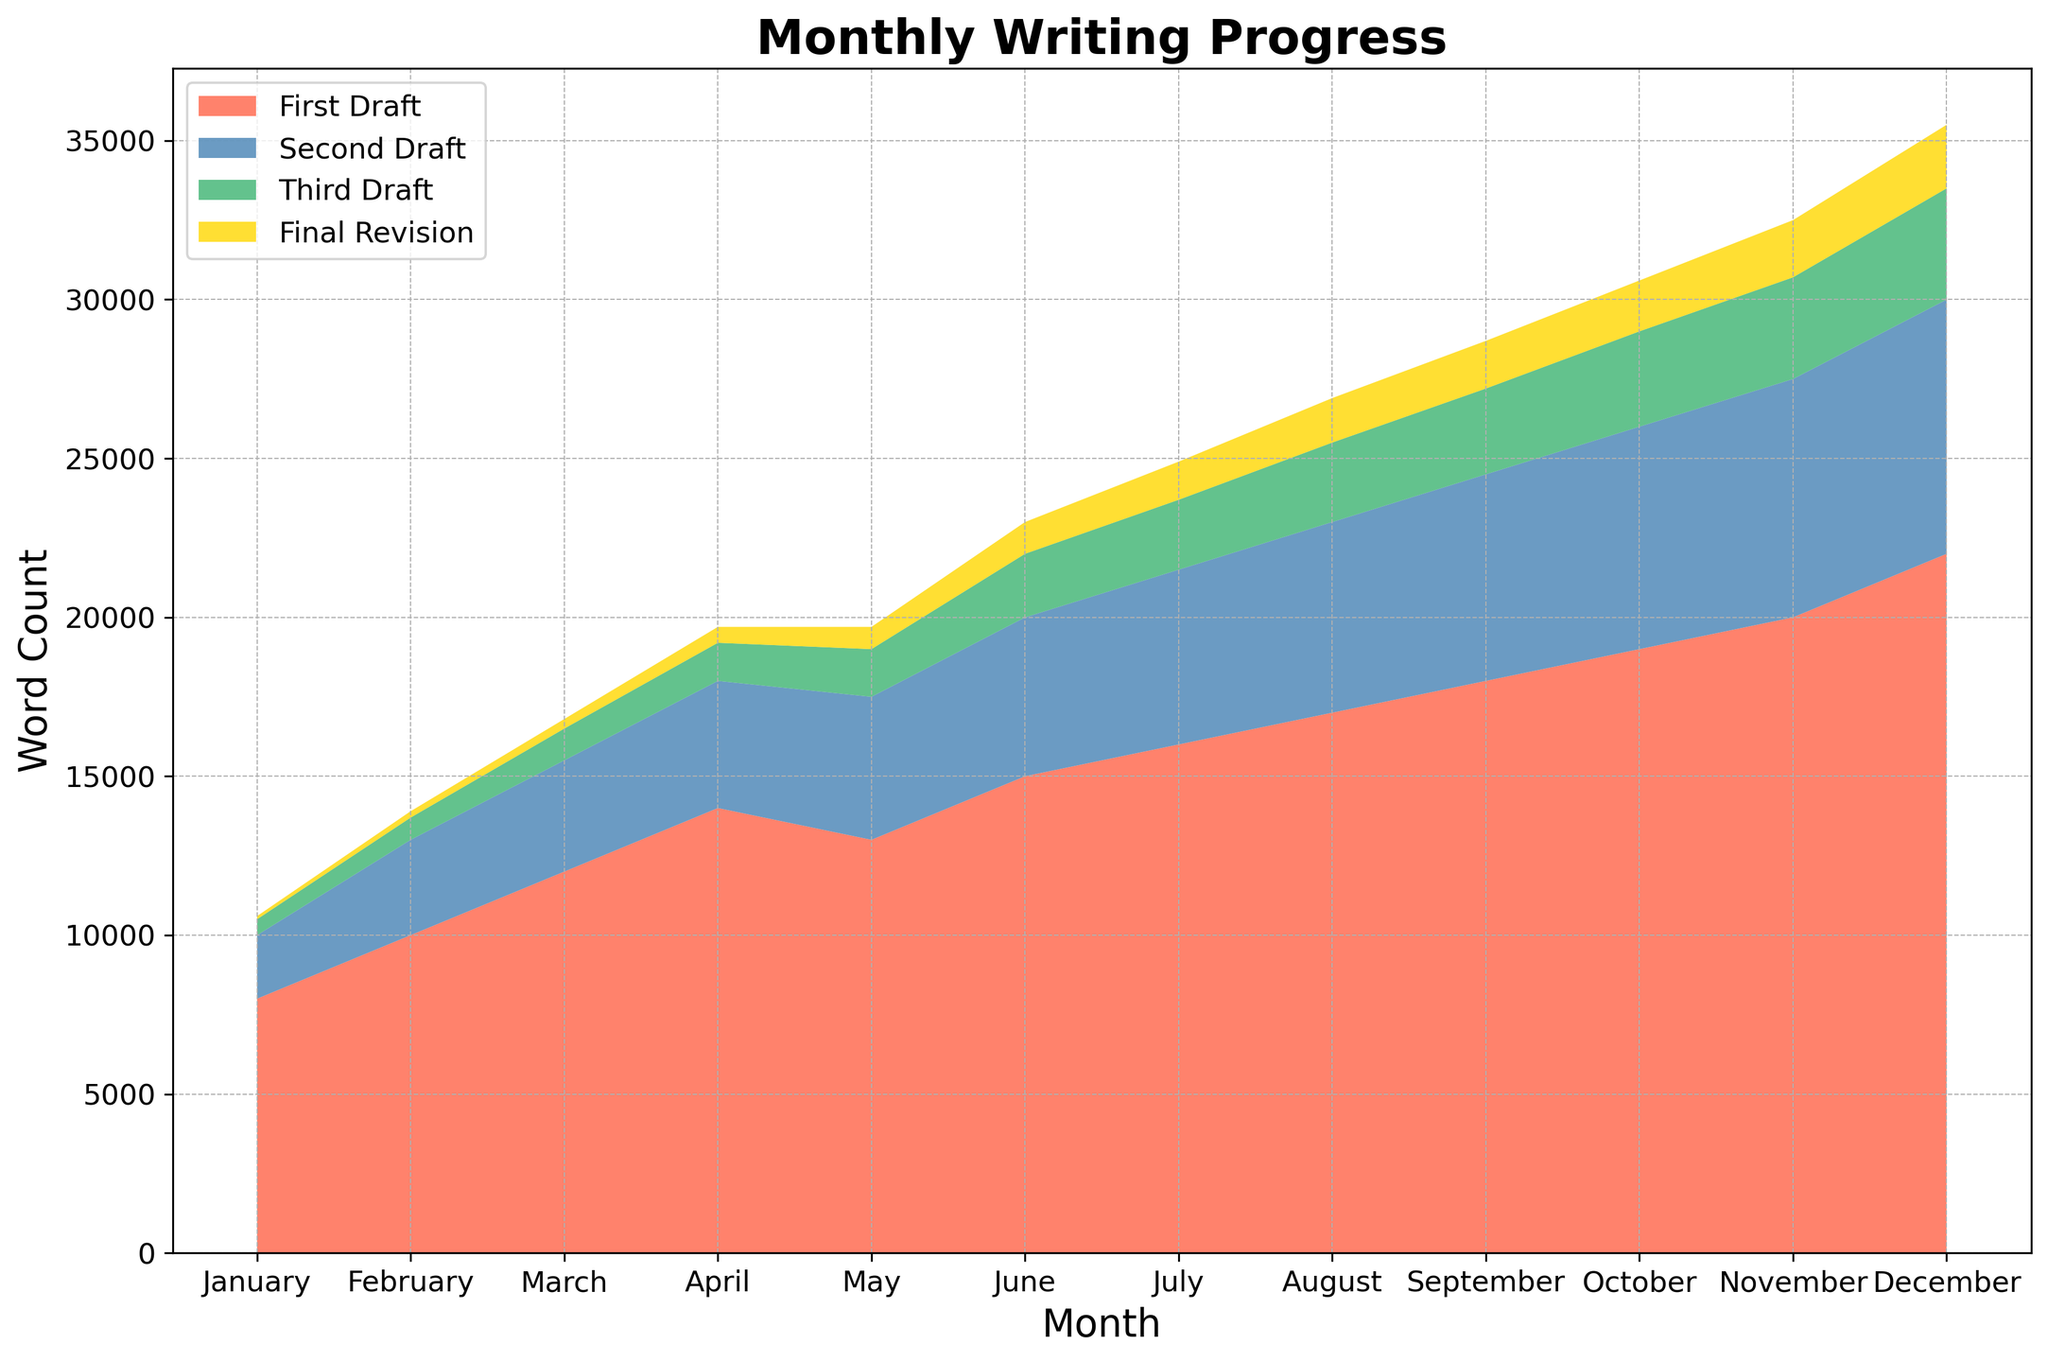What is the total word count progress in December? First, sum the word counts of each draft stage in December: 22000 (First Draft) + 8000 (Second Draft) + 3500 (Third Draft) + 2000 (Final Revision). This gives us a total of 35500 words.
Answer: 35500 Which month had the highest word count for the final revision stage? By comparing the final revision word count for all months, we see that December had the highest word count (2000) in the final revision stage.
Answer: December How does the word count of the first draft in June compare with that in January? The first draft word count in June is 15000, while in January it is 8000. By comparing these values, we see that June has a higher word count than January by 7000 words (15000 - 8000).
Answer: June, by 7000 What is the average word count progression for the second draft over the first half of the year (January to June)? Add the word counts for the second draft from January to June: 2000 + 3000 + 3500 + 4000 + 4500 + 5000 = 22000. Divide this sum by the number of months (6). The average is 22000/6 = 3666.67.
Answer: 3666.67 In which month did the third draft surpass 3000 words? By evaluating the third draft counts, we observe that the third draft surpassed 3000 words in October with a word count of 3000.
Answer: October What is the difference in the total word count progression between July and November? First, sum the word counts for each stage in July: 16000 (First Draft) + 5500 (Second Draft) + 2200 (Third Draft) + 1200 (Final Revision) = 24900. Then, sum the word counts for each stage in November: 20000 (First Draft) + 7500 (Second Draft) + 3200 (Third Draft) + 1800 (Final Revision) = 32500. The difference is 32500 - 24900 = 7600.
Answer: 7600 In which month is the contribution of the final revision stage most visually prominent? Visually examining the areas, we see that the final revision stage becomes thicker and more prominent in the later months, especially in December where it is most prominent.
Answer: December How many times does the first draft’s word count exceed 15000 in the year? The first draft’s word count exceeds 15000 in the months of June (15000), July (16000), August (17000), September (18000), October (19000), November (20000), and December (22000). This happens 7 times.
Answer: 7 times 